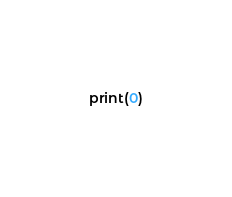<code> <loc_0><loc_0><loc_500><loc_500><_Python_>print(0)</code> 